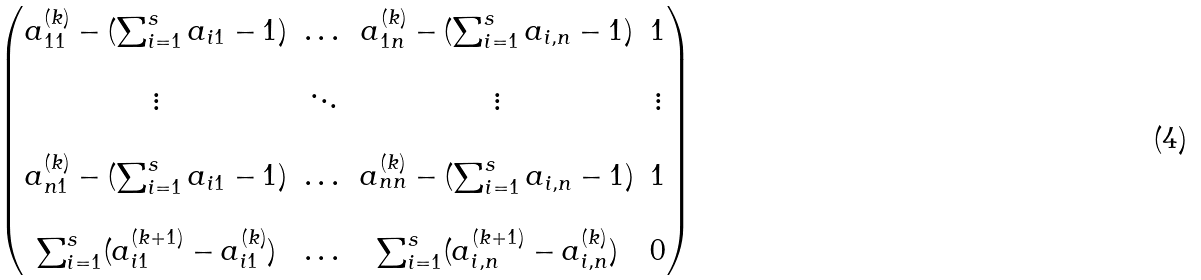<formula> <loc_0><loc_0><loc_500><loc_500>\begin{pmatrix} a _ { 1 1 } ^ { ( k ) } - ( \sum _ { i = 1 } ^ { s } a _ { i 1 } - 1 ) & \dots & a _ { 1 n } ^ { ( k ) } - ( \sum _ { i = 1 } ^ { s } a _ { i , n } - 1 ) & 1 \\ \\ \vdots & \ddots & \vdots & \vdots \\ \\ a _ { n 1 } ^ { ( k ) } - ( \sum _ { i = 1 } ^ { s } a _ { i 1 } - 1 ) & \dots & a _ { n n } ^ { ( k ) } - ( \sum _ { i = 1 } ^ { s } a _ { i , n } - 1 ) & 1 \\ \\ \sum _ { i = 1 } ^ { s } ( a _ { i 1 } ^ { ( k + 1 ) } - a _ { i 1 } ^ { ( k ) } ) & \dots & \sum _ { i = 1 } ^ { s } ( a _ { i , n } ^ { ( k + 1 ) } - a _ { i , n } ^ { ( k ) } ) & 0 \end{pmatrix}</formula> 